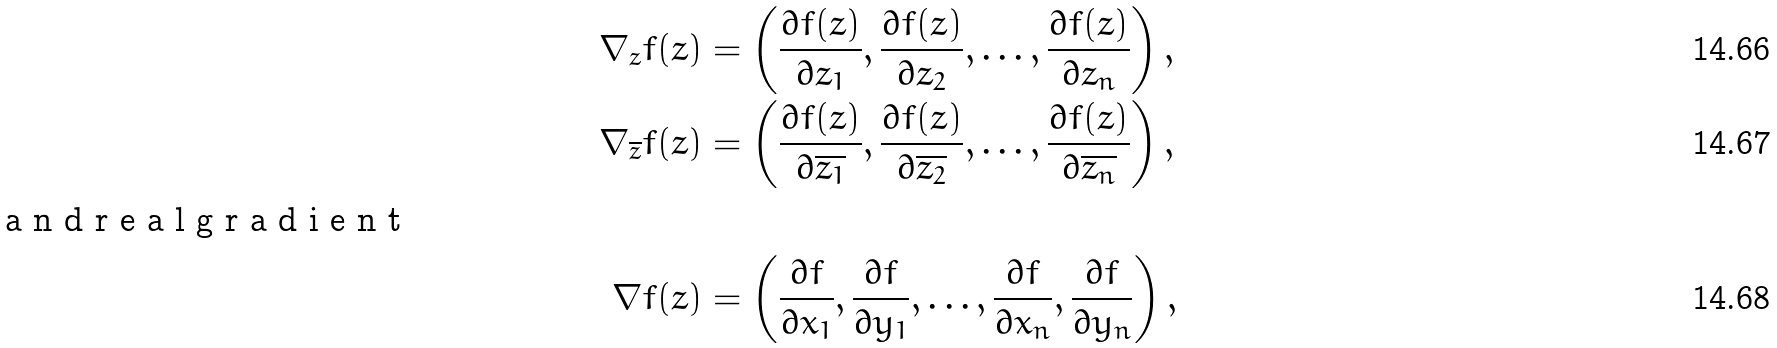<formula> <loc_0><loc_0><loc_500><loc_500>\nabla _ { z } f ( z ) & = \left ( \frac { \partial f ( z ) } { \partial z _ { 1 } } , \frac { \partial f ( z ) } { \partial z _ { 2 } } , \dots , \frac { \partial f ( z ) } { \partial z _ { n } } \right ) , \\ \nabla _ { \overline { z } } f ( z ) & = \left ( \frac { \partial f ( z ) } { \partial \overline { z _ { 1 } } } , \frac { \partial f ( z ) } { \partial \overline { z _ { 2 } } } , \dots , \frac { \partial f ( z ) } { \partial \overline { z _ { n } } } \right ) , \\ \intertext { a n d r e a l g r a d i e n t } \nabla f ( z ) & = \left ( \frac { \partial f } { \partial x _ { 1 } } , \frac { \partial f } { \partial y _ { 1 } } , \dots , \frac { \partial f } { \partial x _ { n } } , \frac { \partial f } { \partial y _ { n } } \right ) ,</formula> 